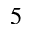<formula> <loc_0><loc_0><loc_500><loc_500>_ { 5 }</formula> 